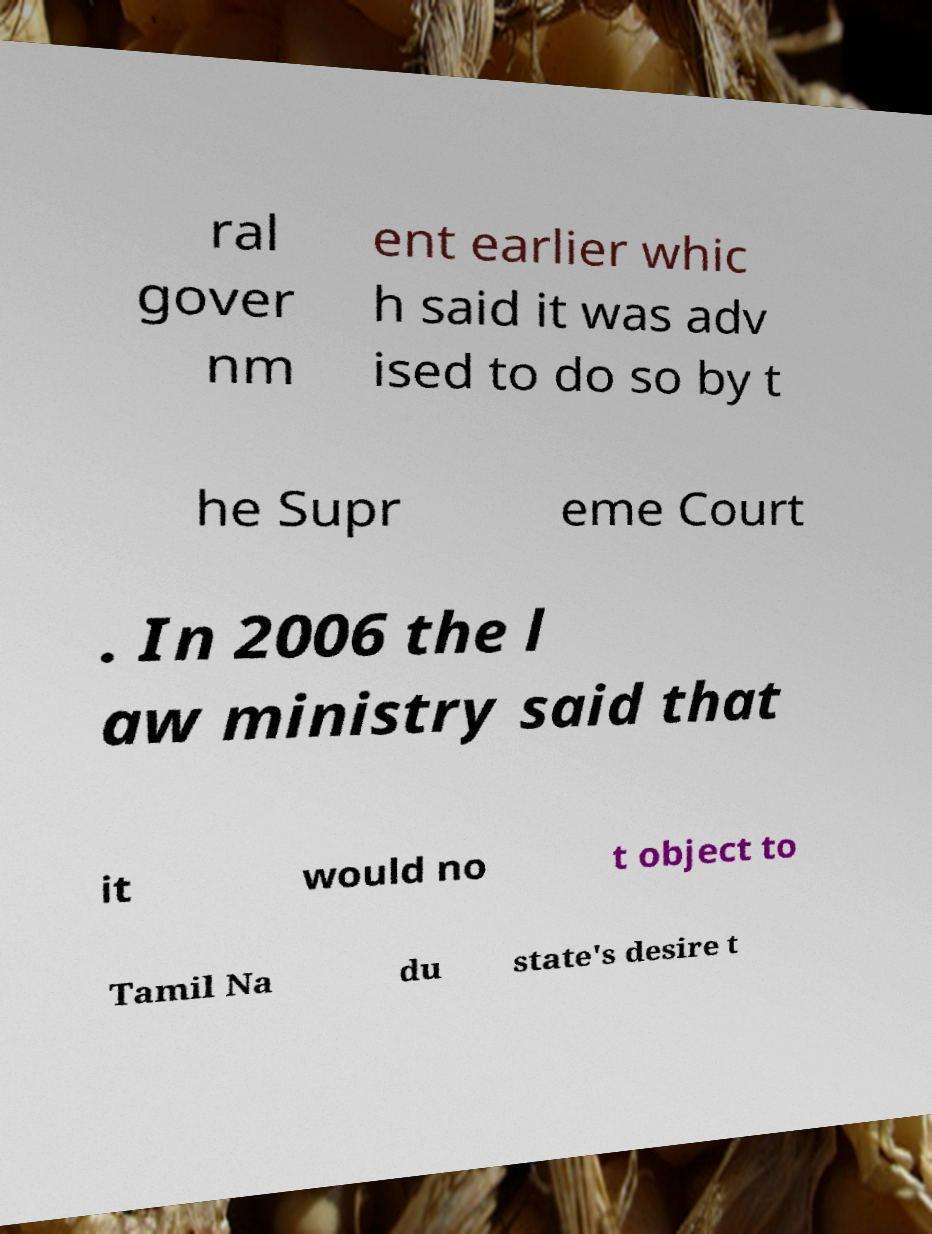Please identify and transcribe the text found in this image. ral gover nm ent earlier whic h said it was adv ised to do so by t he Supr eme Court . In 2006 the l aw ministry said that it would no t object to Tamil Na du state's desire t 